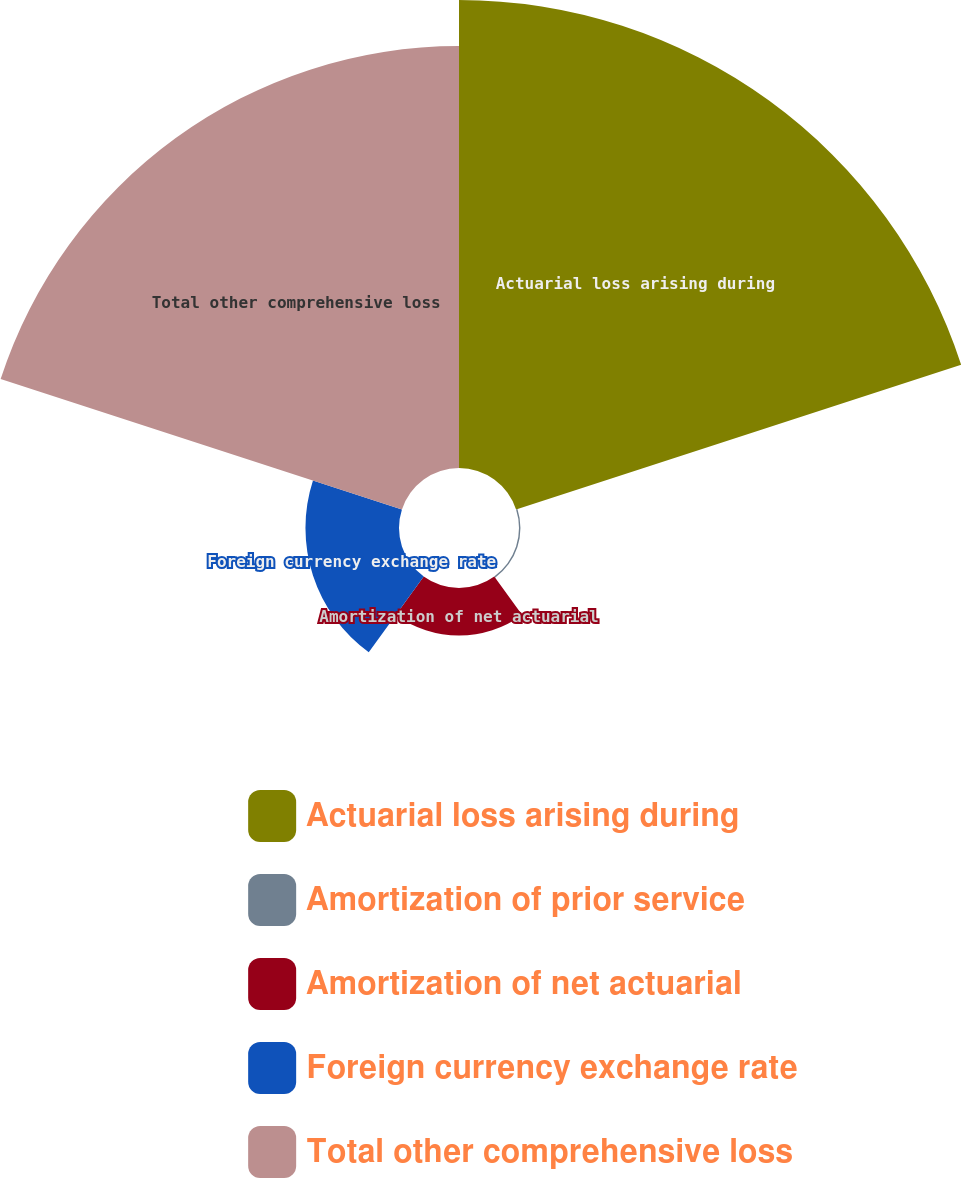<chart> <loc_0><loc_0><loc_500><loc_500><pie_chart><fcel>Actuarial loss arising during<fcel>Amortization of prior service<fcel>Amortization of net actuarial<fcel>Foreign currency exchange rate<fcel>Total other comprehensive loss<nl><fcel>45.33%<fcel>0.14%<fcel>4.6%<fcel>9.06%<fcel>40.87%<nl></chart> 